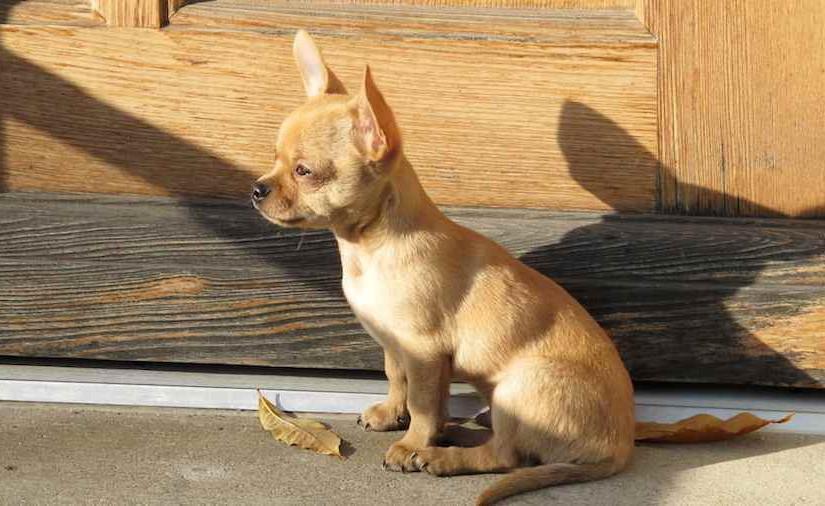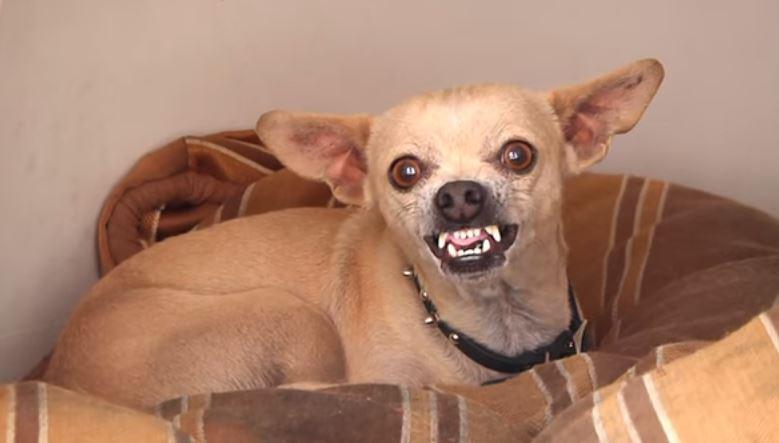The first image is the image on the left, the second image is the image on the right. Given the left and right images, does the statement "Each image includes just one dog." hold true? Answer yes or no. Yes. The first image is the image on the left, the second image is the image on the right. Given the left and right images, does the statement "One of the dogs is outside." hold true? Answer yes or no. Yes. 